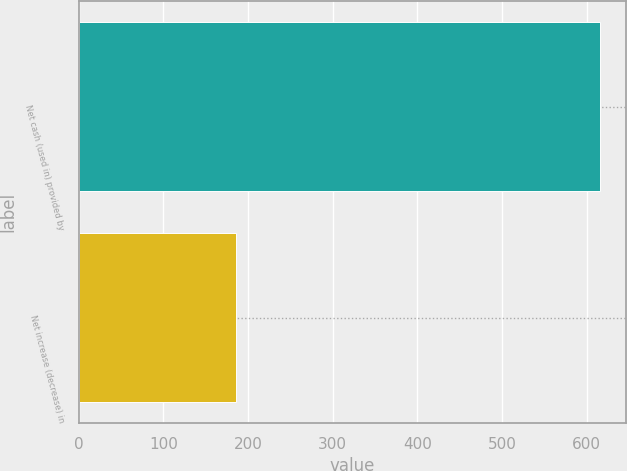<chart> <loc_0><loc_0><loc_500><loc_500><bar_chart><fcel>Net cash (used in) provided by<fcel>Net increase (decrease) in<nl><fcel>616<fcel>185.3<nl></chart> 